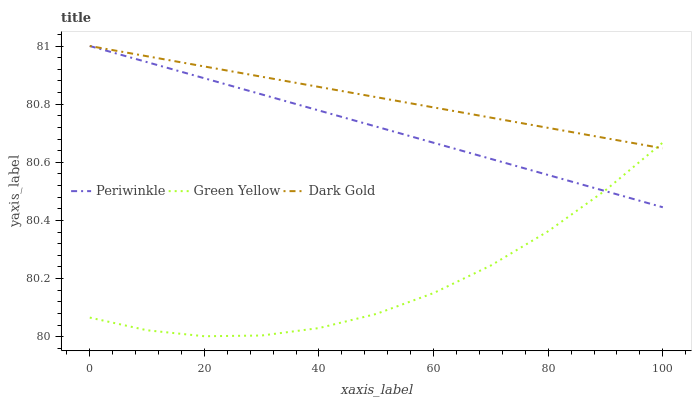Does Periwinkle have the minimum area under the curve?
Answer yes or no. No. Does Periwinkle have the maximum area under the curve?
Answer yes or no. No. Is Periwinkle the smoothest?
Answer yes or no. No. Is Periwinkle the roughest?
Answer yes or no. No. Does Periwinkle have the lowest value?
Answer yes or no. No. 